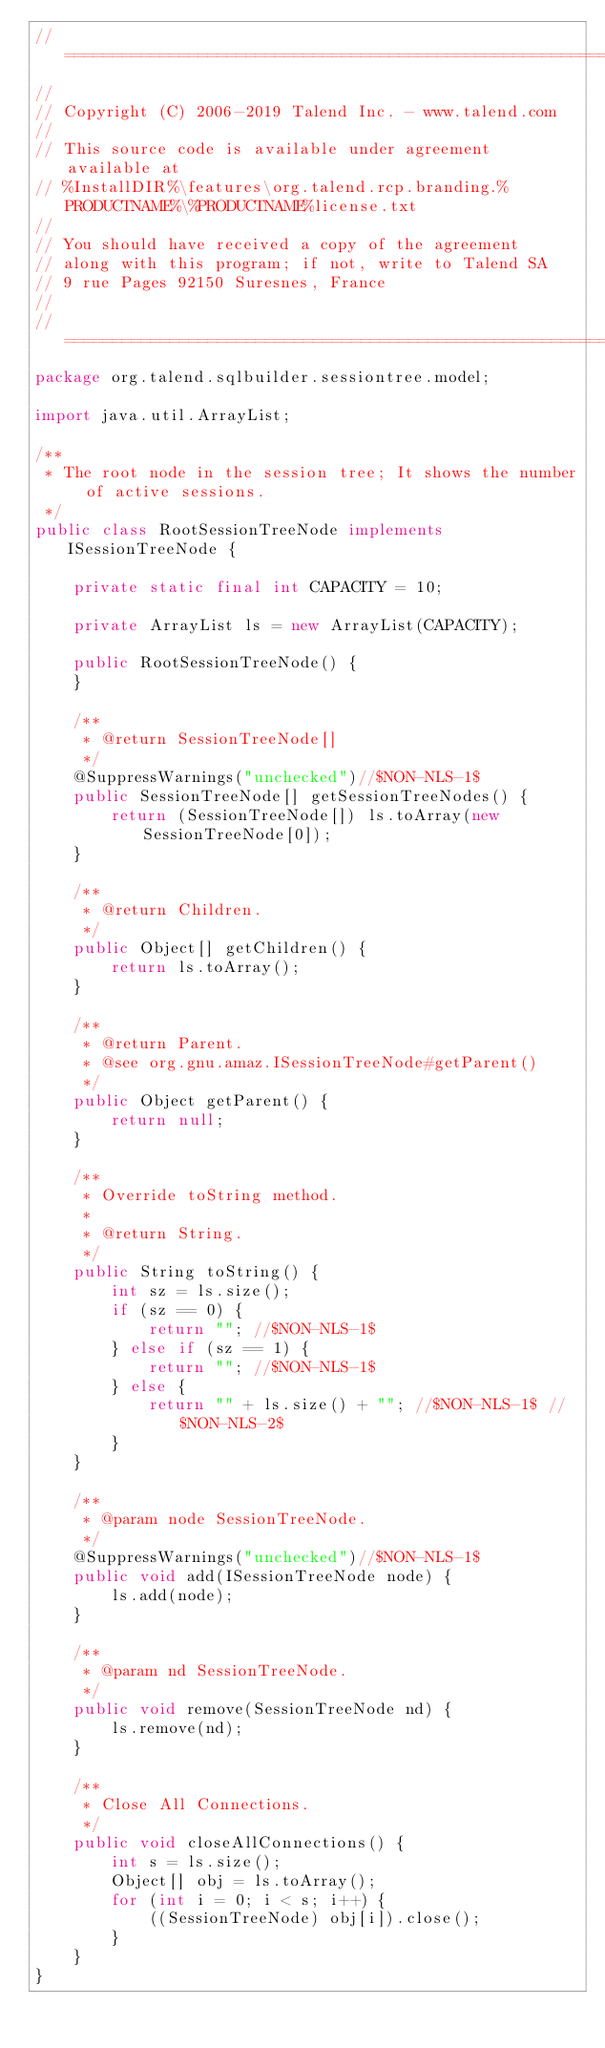<code> <loc_0><loc_0><loc_500><loc_500><_Java_>// ============================================================================
//
// Copyright (C) 2006-2019 Talend Inc. - www.talend.com
//
// This source code is available under agreement available at
// %InstallDIR%\features\org.talend.rcp.branding.%PRODUCTNAME%\%PRODUCTNAME%license.txt
//
// You should have received a copy of the agreement
// along with this program; if not, write to Talend SA
// 9 rue Pages 92150 Suresnes, France
//
// ============================================================================
package org.talend.sqlbuilder.sessiontree.model;

import java.util.ArrayList;

/**
 * The root node in the session tree; It shows the number of active sessions.
 */
public class RootSessionTreeNode implements ISessionTreeNode {

    private static final int CAPACITY = 10;

    private ArrayList ls = new ArrayList(CAPACITY);

    public RootSessionTreeNode() {
    }

    /**
     * @return SessionTreeNode[]
     */
    @SuppressWarnings("unchecked")//$NON-NLS-1$
    public SessionTreeNode[] getSessionTreeNodes() {
        return (SessionTreeNode[]) ls.toArray(new SessionTreeNode[0]);
    }

    /**
     * @return Children.
     */
    public Object[] getChildren() {
        return ls.toArray();
    }

    /**
     * @return Parent.
     * @see org.gnu.amaz.ISessionTreeNode#getParent()
     */
    public Object getParent() {
        return null;
    }

    /**
     * Override toString method.
     *
     * @return String.
     */
    public String toString() {
        int sz = ls.size();
        if (sz == 0) {
            return ""; //$NON-NLS-1$
        } else if (sz == 1) {
            return ""; //$NON-NLS-1$
        } else {
            return "" + ls.size() + ""; //$NON-NLS-1$ //$NON-NLS-2$
        }
    }

    /**
     * @param node SessionTreeNode.
     */
    @SuppressWarnings("unchecked")//$NON-NLS-1$
    public void add(ISessionTreeNode node) {
        ls.add(node);
    }

    /**
     * @param nd SessionTreeNode.
     */
    public void remove(SessionTreeNode nd) {
        ls.remove(nd);
    }

    /**
     * Close All Connections.
     */
    public void closeAllConnections() {
        int s = ls.size();
        Object[] obj = ls.toArray();
        for (int i = 0; i < s; i++) {
            ((SessionTreeNode) obj[i]).close();
        }
    }
}
</code> 